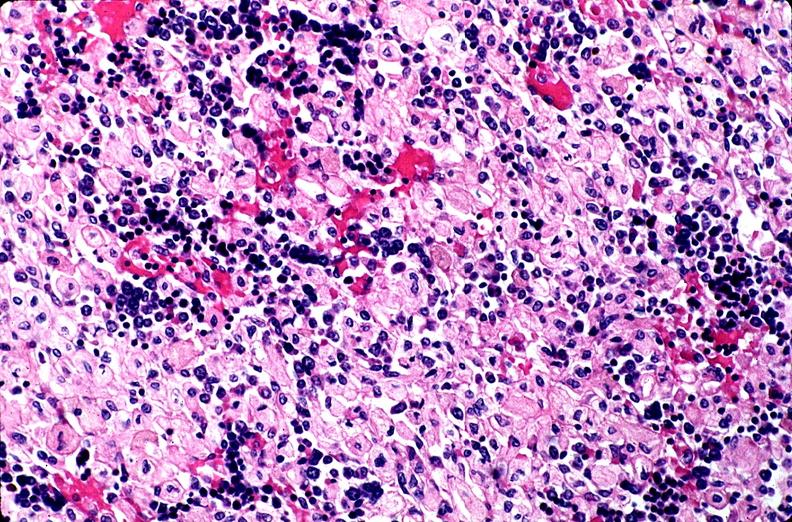what does this image show?
Answer the question using a single word or phrase. Gaucher disease 